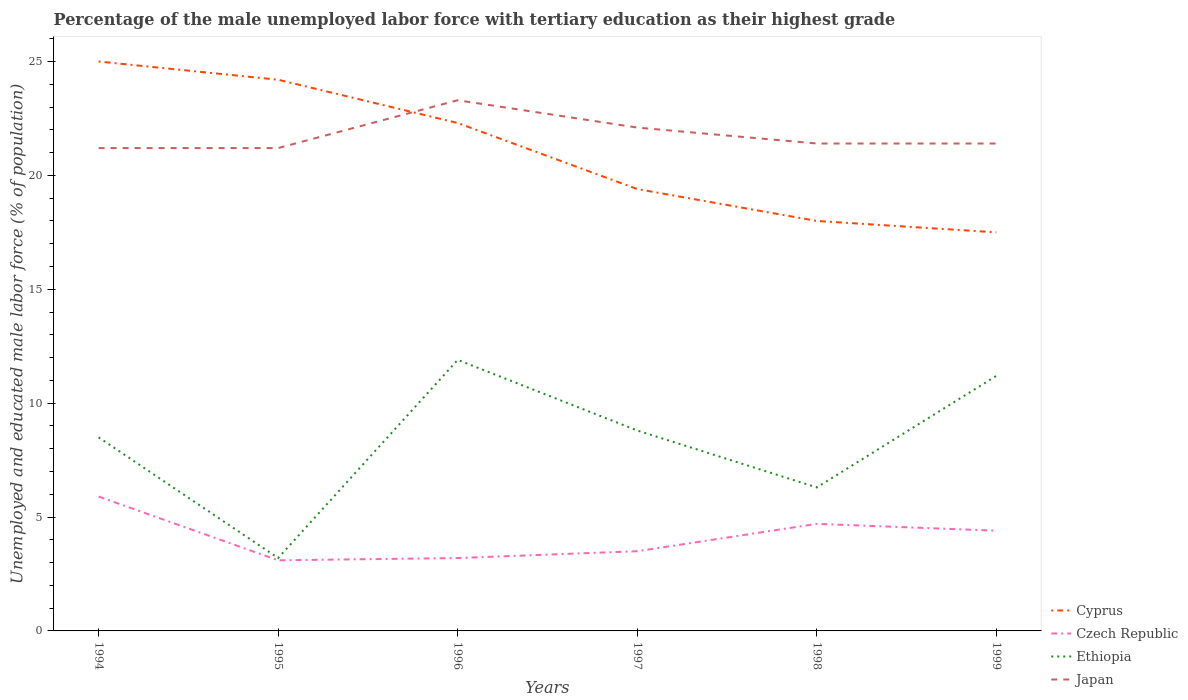How many different coloured lines are there?
Offer a very short reply. 4. Does the line corresponding to Cyprus intersect with the line corresponding to Ethiopia?
Offer a very short reply. No. Is the number of lines equal to the number of legend labels?
Provide a succinct answer. Yes. In which year was the percentage of the unemployed male labor force with tertiary education in Japan maximum?
Your answer should be compact. 1994. What is the total percentage of the unemployed male labor force with tertiary education in Cyprus in the graph?
Your answer should be compact. 4.8. What is the difference between the highest and the second highest percentage of the unemployed male labor force with tertiary education in Czech Republic?
Offer a terse response. 2.8. Is the percentage of the unemployed male labor force with tertiary education in Czech Republic strictly greater than the percentage of the unemployed male labor force with tertiary education in Cyprus over the years?
Give a very brief answer. Yes. How many lines are there?
Your response must be concise. 4. How many years are there in the graph?
Provide a short and direct response. 6. Are the values on the major ticks of Y-axis written in scientific E-notation?
Your answer should be very brief. No. Does the graph contain any zero values?
Keep it short and to the point. No. Does the graph contain grids?
Provide a short and direct response. No. How many legend labels are there?
Offer a very short reply. 4. How are the legend labels stacked?
Offer a very short reply. Vertical. What is the title of the graph?
Ensure brevity in your answer.  Percentage of the male unemployed labor force with tertiary education as their highest grade. Does "Nepal" appear as one of the legend labels in the graph?
Ensure brevity in your answer.  No. What is the label or title of the X-axis?
Keep it short and to the point. Years. What is the label or title of the Y-axis?
Give a very brief answer. Unemployed and educated male labor force (% of population). What is the Unemployed and educated male labor force (% of population) in Czech Republic in 1994?
Make the answer very short. 5.9. What is the Unemployed and educated male labor force (% of population) in Japan in 1994?
Give a very brief answer. 21.2. What is the Unemployed and educated male labor force (% of population) of Cyprus in 1995?
Give a very brief answer. 24.2. What is the Unemployed and educated male labor force (% of population) of Czech Republic in 1995?
Ensure brevity in your answer.  3.1. What is the Unemployed and educated male labor force (% of population) of Ethiopia in 1995?
Offer a terse response. 3.2. What is the Unemployed and educated male labor force (% of population) of Japan in 1995?
Your answer should be compact. 21.2. What is the Unemployed and educated male labor force (% of population) of Cyprus in 1996?
Make the answer very short. 22.3. What is the Unemployed and educated male labor force (% of population) in Czech Republic in 1996?
Ensure brevity in your answer.  3.2. What is the Unemployed and educated male labor force (% of population) in Ethiopia in 1996?
Give a very brief answer. 11.9. What is the Unemployed and educated male labor force (% of population) in Japan in 1996?
Provide a short and direct response. 23.3. What is the Unemployed and educated male labor force (% of population) of Cyprus in 1997?
Keep it short and to the point. 19.4. What is the Unemployed and educated male labor force (% of population) of Ethiopia in 1997?
Your answer should be very brief. 8.8. What is the Unemployed and educated male labor force (% of population) in Japan in 1997?
Your answer should be very brief. 22.1. What is the Unemployed and educated male labor force (% of population) in Cyprus in 1998?
Offer a very short reply. 18. What is the Unemployed and educated male labor force (% of population) in Czech Republic in 1998?
Provide a succinct answer. 4.7. What is the Unemployed and educated male labor force (% of population) in Ethiopia in 1998?
Your answer should be very brief. 6.3. What is the Unemployed and educated male labor force (% of population) of Japan in 1998?
Provide a short and direct response. 21.4. What is the Unemployed and educated male labor force (% of population) in Cyprus in 1999?
Offer a very short reply. 17.5. What is the Unemployed and educated male labor force (% of population) in Czech Republic in 1999?
Ensure brevity in your answer.  4.4. What is the Unemployed and educated male labor force (% of population) of Ethiopia in 1999?
Provide a succinct answer. 11.2. What is the Unemployed and educated male labor force (% of population) in Japan in 1999?
Your answer should be compact. 21.4. Across all years, what is the maximum Unemployed and educated male labor force (% of population) of Czech Republic?
Keep it short and to the point. 5.9. Across all years, what is the maximum Unemployed and educated male labor force (% of population) in Ethiopia?
Provide a succinct answer. 11.9. Across all years, what is the maximum Unemployed and educated male labor force (% of population) in Japan?
Offer a very short reply. 23.3. Across all years, what is the minimum Unemployed and educated male labor force (% of population) in Czech Republic?
Ensure brevity in your answer.  3.1. Across all years, what is the minimum Unemployed and educated male labor force (% of population) in Ethiopia?
Provide a succinct answer. 3.2. Across all years, what is the minimum Unemployed and educated male labor force (% of population) of Japan?
Provide a succinct answer. 21.2. What is the total Unemployed and educated male labor force (% of population) in Cyprus in the graph?
Give a very brief answer. 126.4. What is the total Unemployed and educated male labor force (% of population) in Czech Republic in the graph?
Your answer should be compact. 24.8. What is the total Unemployed and educated male labor force (% of population) of Ethiopia in the graph?
Ensure brevity in your answer.  49.9. What is the total Unemployed and educated male labor force (% of population) in Japan in the graph?
Ensure brevity in your answer.  130.6. What is the difference between the Unemployed and educated male labor force (% of population) of Cyprus in 1994 and that in 1995?
Your response must be concise. 0.8. What is the difference between the Unemployed and educated male labor force (% of population) in Czech Republic in 1994 and that in 1995?
Ensure brevity in your answer.  2.8. What is the difference between the Unemployed and educated male labor force (% of population) in Cyprus in 1994 and that in 1996?
Provide a succinct answer. 2.7. What is the difference between the Unemployed and educated male labor force (% of population) of Czech Republic in 1994 and that in 1996?
Give a very brief answer. 2.7. What is the difference between the Unemployed and educated male labor force (% of population) in Ethiopia in 1994 and that in 1996?
Keep it short and to the point. -3.4. What is the difference between the Unemployed and educated male labor force (% of population) in Japan in 1994 and that in 1996?
Provide a succinct answer. -2.1. What is the difference between the Unemployed and educated male labor force (% of population) of Czech Republic in 1994 and that in 1997?
Offer a very short reply. 2.4. What is the difference between the Unemployed and educated male labor force (% of population) of Ethiopia in 1994 and that in 1997?
Your response must be concise. -0.3. What is the difference between the Unemployed and educated male labor force (% of population) of Cyprus in 1994 and that in 1998?
Your answer should be very brief. 7. What is the difference between the Unemployed and educated male labor force (% of population) of Japan in 1994 and that in 1998?
Your answer should be very brief. -0.2. What is the difference between the Unemployed and educated male labor force (% of population) in Czech Republic in 1994 and that in 1999?
Offer a terse response. 1.5. What is the difference between the Unemployed and educated male labor force (% of population) of Ethiopia in 1994 and that in 1999?
Ensure brevity in your answer.  -2.7. What is the difference between the Unemployed and educated male labor force (% of population) in Cyprus in 1995 and that in 1996?
Your answer should be compact. 1.9. What is the difference between the Unemployed and educated male labor force (% of population) of Czech Republic in 1995 and that in 1997?
Offer a terse response. -0.4. What is the difference between the Unemployed and educated male labor force (% of population) in Japan in 1995 and that in 1997?
Your answer should be very brief. -0.9. What is the difference between the Unemployed and educated male labor force (% of population) of Cyprus in 1995 and that in 1998?
Offer a terse response. 6.2. What is the difference between the Unemployed and educated male labor force (% of population) of Czech Republic in 1995 and that in 1998?
Provide a succinct answer. -1.6. What is the difference between the Unemployed and educated male labor force (% of population) of Japan in 1995 and that in 1998?
Your response must be concise. -0.2. What is the difference between the Unemployed and educated male labor force (% of population) of Ethiopia in 1995 and that in 1999?
Your answer should be very brief. -8. What is the difference between the Unemployed and educated male labor force (% of population) of Japan in 1995 and that in 1999?
Give a very brief answer. -0.2. What is the difference between the Unemployed and educated male labor force (% of population) of Ethiopia in 1996 and that in 1997?
Offer a very short reply. 3.1. What is the difference between the Unemployed and educated male labor force (% of population) in Japan in 1996 and that in 1997?
Offer a very short reply. 1.2. What is the difference between the Unemployed and educated male labor force (% of population) in Cyprus in 1996 and that in 1998?
Make the answer very short. 4.3. What is the difference between the Unemployed and educated male labor force (% of population) in Czech Republic in 1996 and that in 1998?
Provide a succinct answer. -1.5. What is the difference between the Unemployed and educated male labor force (% of population) of Japan in 1996 and that in 1998?
Your answer should be compact. 1.9. What is the difference between the Unemployed and educated male labor force (% of population) of Cyprus in 1996 and that in 1999?
Your answer should be very brief. 4.8. What is the difference between the Unemployed and educated male labor force (% of population) in Ethiopia in 1996 and that in 1999?
Your answer should be very brief. 0.7. What is the difference between the Unemployed and educated male labor force (% of population) of Japan in 1996 and that in 1999?
Offer a terse response. 1.9. What is the difference between the Unemployed and educated male labor force (% of population) of Cyprus in 1997 and that in 1998?
Offer a very short reply. 1.4. What is the difference between the Unemployed and educated male labor force (% of population) of Czech Republic in 1997 and that in 1998?
Provide a short and direct response. -1.2. What is the difference between the Unemployed and educated male labor force (% of population) in Czech Republic in 1997 and that in 1999?
Give a very brief answer. -0.9. What is the difference between the Unemployed and educated male labor force (% of population) in Japan in 1997 and that in 1999?
Provide a short and direct response. 0.7. What is the difference between the Unemployed and educated male labor force (% of population) of Ethiopia in 1998 and that in 1999?
Your answer should be very brief. -4.9. What is the difference between the Unemployed and educated male labor force (% of population) of Cyprus in 1994 and the Unemployed and educated male labor force (% of population) of Czech Republic in 1995?
Ensure brevity in your answer.  21.9. What is the difference between the Unemployed and educated male labor force (% of population) of Cyprus in 1994 and the Unemployed and educated male labor force (% of population) of Ethiopia in 1995?
Make the answer very short. 21.8. What is the difference between the Unemployed and educated male labor force (% of population) of Cyprus in 1994 and the Unemployed and educated male labor force (% of population) of Japan in 1995?
Your response must be concise. 3.8. What is the difference between the Unemployed and educated male labor force (% of population) of Czech Republic in 1994 and the Unemployed and educated male labor force (% of population) of Ethiopia in 1995?
Provide a short and direct response. 2.7. What is the difference between the Unemployed and educated male labor force (% of population) in Czech Republic in 1994 and the Unemployed and educated male labor force (% of population) in Japan in 1995?
Your answer should be compact. -15.3. What is the difference between the Unemployed and educated male labor force (% of population) in Ethiopia in 1994 and the Unemployed and educated male labor force (% of population) in Japan in 1995?
Your answer should be very brief. -12.7. What is the difference between the Unemployed and educated male labor force (% of population) in Cyprus in 1994 and the Unemployed and educated male labor force (% of population) in Czech Republic in 1996?
Provide a short and direct response. 21.8. What is the difference between the Unemployed and educated male labor force (% of population) in Cyprus in 1994 and the Unemployed and educated male labor force (% of population) in Ethiopia in 1996?
Provide a short and direct response. 13.1. What is the difference between the Unemployed and educated male labor force (% of population) of Czech Republic in 1994 and the Unemployed and educated male labor force (% of population) of Japan in 1996?
Your response must be concise. -17.4. What is the difference between the Unemployed and educated male labor force (% of population) of Ethiopia in 1994 and the Unemployed and educated male labor force (% of population) of Japan in 1996?
Provide a succinct answer. -14.8. What is the difference between the Unemployed and educated male labor force (% of population) of Cyprus in 1994 and the Unemployed and educated male labor force (% of population) of Czech Republic in 1997?
Offer a terse response. 21.5. What is the difference between the Unemployed and educated male labor force (% of population) in Cyprus in 1994 and the Unemployed and educated male labor force (% of population) in Ethiopia in 1997?
Offer a terse response. 16.2. What is the difference between the Unemployed and educated male labor force (% of population) of Cyprus in 1994 and the Unemployed and educated male labor force (% of population) of Japan in 1997?
Offer a very short reply. 2.9. What is the difference between the Unemployed and educated male labor force (% of population) in Czech Republic in 1994 and the Unemployed and educated male labor force (% of population) in Japan in 1997?
Provide a short and direct response. -16.2. What is the difference between the Unemployed and educated male labor force (% of population) of Ethiopia in 1994 and the Unemployed and educated male labor force (% of population) of Japan in 1997?
Your answer should be very brief. -13.6. What is the difference between the Unemployed and educated male labor force (% of population) of Cyprus in 1994 and the Unemployed and educated male labor force (% of population) of Czech Republic in 1998?
Your answer should be compact. 20.3. What is the difference between the Unemployed and educated male labor force (% of population) of Cyprus in 1994 and the Unemployed and educated male labor force (% of population) of Japan in 1998?
Offer a terse response. 3.6. What is the difference between the Unemployed and educated male labor force (% of population) in Czech Republic in 1994 and the Unemployed and educated male labor force (% of population) in Ethiopia in 1998?
Ensure brevity in your answer.  -0.4. What is the difference between the Unemployed and educated male labor force (% of population) of Czech Republic in 1994 and the Unemployed and educated male labor force (% of population) of Japan in 1998?
Your answer should be very brief. -15.5. What is the difference between the Unemployed and educated male labor force (% of population) of Ethiopia in 1994 and the Unemployed and educated male labor force (% of population) of Japan in 1998?
Provide a succinct answer. -12.9. What is the difference between the Unemployed and educated male labor force (% of population) in Cyprus in 1994 and the Unemployed and educated male labor force (% of population) in Czech Republic in 1999?
Provide a succinct answer. 20.6. What is the difference between the Unemployed and educated male labor force (% of population) of Cyprus in 1994 and the Unemployed and educated male labor force (% of population) of Ethiopia in 1999?
Give a very brief answer. 13.8. What is the difference between the Unemployed and educated male labor force (% of population) in Czech Republic in 1994 and the Unemployed and educated male labor force (% of population) in Japan in 1999?
Offer a very short reply. -15.5. What is the difference between the Unemployed and educated male labor force (% of population) of Cyprus in 1995 and the Unemployed and educated male labor force (% of population) of Japan in 1996?
Make the answer very short. 0.9. What is the difference between the Unemployed and educated male labor force (% of population) of Czech Republic in 1995 and the Unemployed and educated male labor force (% of population) of Ethiopia in 1996?
Your response must be concise. -8.8. What is the difference between the Unemployed and educated male labor force (% of population) of Czech Republic in 1995 and the Unemployed and educated male labor force (% of population) of Japan in 1996?
Offer a very short reply. -20.2. What is the difference between the Unemployed and educated male labor force (% of population) in Ethiopia in 1995 and the Unemployed and educated male labor force (% of population) in Japan in 1996?
Your response must be concise. -20.1. What is the difference between the Unemployed and educated male labor force (% of population) of Cyprus in 1995 and the Unemployed and educated male labor force (% of population) of Czech Republic in 1997?
Your response must be concise. 20.7. What is the difference between the Unemployed and educated male labor force (% of population) in Cyprus in 1995 and the Unemployed and educated male labor force (% of population) in Japan in 1997?
Offer a very short reply. 2.1. What is the difference between the Unemployed and educated male labor force (% of population) of Ethiopia in 1995 and the Unemployed and educated male labor force (% of population) of Japan in 1997?
Offer a very short reply. -18.9. What is the difference between the Unemployed and educated male labor force (% of population) of Cyprus in 1995 and the Unemployed and educated male labor force (% of population) of Czech Republic in 1998?
Make the answer very short. 19.5. What is the difference between the Unemployed and educated male labor force (% of population) in Czech Republic in 1995 and the Unemployed and educated male labor force (% of population) in Japan in 1998?
Provide a succinct answer. -18.3. What is the difference between the Unemployed and educated male labor force (% of population) of Ethiopia in 1995 and the Unemployed and educated male labor force (% of population) of Japan in 1998?
Offer a terse response. -18.2. What is the difference between the Unemployed and educated male labor force (% of population) of Cyprus in 1995 and the Unemployed and educated male labor force (% of population) of Czech Republic in 1999?
Your response must be concise. 19.8. What is the difference between the Unemployed and educated male labor force (% of population) in Cyprus in 1995 and the Unemployed and educated male labor force (% of population) in Japan in 1999?
Your answer should be very brief. 2.8. What is the difference between the Unemployed and educated male labor force (% of population) in Czech Republic in 1995 and the Unemployed and educated male labor force (% of population) in Japan in 1999?
Keep it short and to the point. -18.3. What is the difference between the Unemployed and educated male labor force (% of population) in Ethiopia in 1995 and the Unemployed and educated male labor force (% of population) in Japan in 1999?
Make the answer very short. -18.2. What is the difference between the Unemployed and educated male labor force (% of population) of Cyprus in 1996 and the Unemployed and educated male labor force (% of population) of Japan in 1997?
Give a very brief answer. 0.2. What is the difference between the Unemployed and educated male labor force (% of population) in Czech Republic in 1996 and the Unemployed and educated male labor force (% of population) in Japan in 1997?
Offer a terse response. -18.9. What is the difference between the Unemployed and educated male labor force (% of population) in Cyprus in 1996 and the Unemployed and educated male labor force (% of population) in Czech Republic in 1998?
Ensure brevity in your answer.  17.6. What is the difference between the Unemployed and educated male labor force (% of population) of Czech Republic in 1996 and the Unemployed and educated male labor force (% of population) of Japan in 1998?
Give a very brief answer. -18.2. What is the difference between the Unemployed and educated male labor force (% of population) of Ethiopia in 1996 and the Unemployed and educated male labor force (% of population) of Japan in 1998?
Offer a terse response. -9.5. What is the difference between the Unemployed and educated male labor force (% of population) in Cyprus in 1996 and the Unemployed and educated male labor force (% of population) in Japan in 1999?
Give a very brief answer. 0.9. What is the difference between the Unemployed and educated male labor force (% of population) in Czech Republic in 1996 and the Unemployed and educated male labor force (% of population) in Japan in 1999?
Your response must be concise. -18.2. What is the difference between the Unemployed and educated male labor force (% of population) of Ethiopia in 1996 and the Unemployed and educated male labor force (% of population) of Japan in 1999?
Make the answer very short. -9.5. What is the difference between the Unemployed and educated male labor force (% of population) in Cyprus in 1997 and the Unemployed and educated male labor force (% of population) in Czech Republic in 1998?
Keep it short and to the point. 14.7. What is the difference between the Unemployed and educated male labor force (% of population) in Cyprus in 1997 and the Unemployed and educated male labor force (% of population) in Ethiopia in 1998?
Your answer should be compact. 13.1. What is the difference between the Unemployed and educated male labor force (% of population) in Czech Republic in 1997 and the Unemployed and educated male labor force (% of population) in Japan in 1998?
Your answer should be very brief. -17.9. What is the difference between the Unemployed and educated male labor force (% of population) of Ethiopia in 1997 and the Unemployed and educated male labor force (% of population) of Japan in 1998?
Your answer should be compact. -12.6. What is the difference between the Unemployed and educated male labor force (% of population) of Cyprus in 1997 and the Unemployed and educated male labor force (% of population) of Ethiopia in 1999?
Your answer should be very brief. 8.2. What is the difference between the Unemployed and educated male labor force (% of population) in Cyprus in 1997 and the Unemployed and educated male labor force (% of population) in Japan in 1999?
Provide a succinct answer. -2. What is the difference between the Unemployed and educated male labor force (% of population) in Czech Republic in 1997 and the Unemployed and educated male labor force (% of population) in Japan in 1999?
Your response must be concise. -17.9. What is the difference between the Unemployed and educated male labor force (% of population) of Cyprus in 1998 and the Unemployed and educated male labor force (% of population) of Ethiopia in 1999?
Provide a short and direct response. 6.8. What is the difference between the Unemployed and educated male labor force (% of population) of Czech Republic in 1998 and the Unemployed and educated male labor force (% of population) of Japan in 1999?
Make the answer very short. -16.7. What is the difference between the Unemployed and educated male labor force (% of population) of Ethiopia in 1998 and the Unemployed and educated male labor force (% of population) of Japan in 1999?
Keep it short and to the point. -15.1. What is the average Unemployed and educated male labor force (% of population) of Cyprus per year?
Your answer should be very brief. 21.07. What is the average Unemployed and educated male labor force (% of population) of Czech Republic per year?
Provide a succinct answer. 4.13. What is the average Unemployed and educated male labor force (% of population) of Ethiopia per year?
Your answer should be very brief. 8.32. What is the average Unemployed and educated male labor force (% of population) in Japan per year?
Your answer should be very brief. 21.77. In the year 1994, what is the difference between the Unemployed and educated male labor force (% of population) in Cyprus and Unemployed and educated male labor force (% of population) in Czech Republic?
Your response must be concise. 19.1. In the year 1994, what is the difference between the Unemployed and educated male labor force (% of population) of Czech Republic and Unemployed and educated male labor force (% of population) of Japan?
Ensure brevity in your answer.  -15.3. In the year 1995, what is the difference between the Unemployed and educated male labor force (% of population) in Cyprus and Unemployed and educated male labor force (% of population) in Czech Republic?
Ensure brevity in your answer.  21.1. In the year 1995, what is the difference between the Unemployed and educated male labor force (% of population) of Cyprus and Unemployed and educated male labor force (% of population) of Japan?
Your response must be concise. 3. In the year 1995, what is the difference between the Unemployed and educated male labor force (% of population) of Czech Republic and Unemployed and educated male labor force (% of population) of Japan?
Provide a short and direct response. -18.1. In the year 1995, what is the difference between the Unemployed and educated male labor force (% of population) in Ethiopia and Unemployed and educated male labor force (% of population) in Japan?
Ensure brevity in your answer.  -18. In the year 1996, what is the difference between the Unemployed and educated male labor force (% of population) of Cyprus and Unemployed and educated male labor force (% of population) of Ethiopia?
Offer a terse response. 10.4. In the year 1996, what is the difference between the Unemployed and educated male labor force (% of population) in Czech Republic and Unemployed and educated male labor force (% of population) in Japan?
Your answer should be very brief. -20.1. In the year 1996, what is the difference between the Unemployed and educated male labor force (% of population) of Ethiopia and Unemployed and educated male labor force (% of population) of Japan?
Ensure brevity in your answer.  -11.4. In the year 1997, what is the difference between the Unemployed and educated male labor force (% of population) of Cyprus and Unemployed and educated male labor force (% of population) of Czech Republic?
Provide a succinct answer. 15.9. In the year 1997, what is the difference between the Unemployed and educated male labor force (% of population) of Czech Republic and Unemployed and educated male labor force (% of population) of Japan?
Your answer should be compact. -18.6. In the year 1998, what is the difference between the Unemployed and educated male labor force (% of population) in Cyprus and Unemployed and educated male labor force (% of population) in Japan?
Offer a terse response. -3.4. In the year 1998, what is the difference between the Unemployed and educated male labor force (% of population) in Czech Republic and Unemployed and educated male labor force (% of population) in Ethiopia?
Ensure brevity in your answer.  -1.6. In the year 1998, what is the difference between the Unemployed and educated male labor force (% of population) of Czech Republic and Unemployed and educated male labor force (% of population) of Japan?
Your answer should be very brief. -16.7. In the year 1998, what is the difference between the Unemployed and educated male labor force (% of population) of Ethiopia and Unemployed and educated male labor force (% of population) of Japan?
Make the answer very short. -15.1. In the year 1999, what is the difference between the Unemployed and educated male labor force (% of population) of Czech Republic and Unemployed and educated male labor force (% of population) of Japan?
Provide a short and direct response. -17. In the year 1999, what is the difference between the Unemployed and educated male labor force (% of population) of Ethiopia and Unemployed and educated male labor force (% of population) of Japan?
Your response must be concise. -10.2. What is the ratio of the Unemployed and educated male labor force (% of population) in Cyprus in 1994 to that in 1995?
Give a very brief answer. 1.03. What is the ratio of the Unemployed and educated male labor force (% of population) in Czech Republic in 1994 to that in 1995?
Ensure brevity in your answer.  1.9. What is the ratio of the Unemployed and educated male labor force (% of population) of Ethiopia in 1994 to that in 1995?
Provide a succinct answer. 2.66. What is the ratio of the Unemployed and educated male labor force (% of population) in Cyprus in 1994 to that in 1996?
Provide a succinct answer. 1.12. What is the ratio of the Unemployed and educated male labor force (% of population) of Czech Republic in 1994 to that in 1996?
Make the answer very short. 1.84. What is the ratio of the Unemployed and educated male labor force (% of population) in Ethiopia in 1994 to that in 1996?
Your answer should be compact. 0.71. What is the ratio of the Unemployed and educated male labor force (% of population) of Japan in 1994 to that in 1996?
Keep it short and to the point. 0.91. What is the ratio of the Unemployed and educated male labor force (% of population) in Cyprus in 1994 to that in 1997?
Make the answer very short. 1.29. What is the ratio of the Unemployed and educated male labor force (% of population) of Czech Republic in 1994 to that in 1997?
Your answer should be very brief. 1.69. What is the ratio of the Unemployed and educated male labor force (% of population) in Ethiopia in 1994 to that in 1997?
Provide a short and direct response. 0.97. What is the ratio of the Unemployed and educated male labor force (% of population) of Japan in 1994 to that in 1997?
Your answer should be compact. 0.96. What is the ratio of the Unemployed and educated male labor force (% of population) of Cyprus in 1994 to that in 1998?
Keep it short and to the point. 1.39. What is the ratio of the Unemployed and educated male labor force (% of population) of Czech Republic in 1994 to that in 1998?
Your answer should be very brief. 1.26. What is the ratio of the Unemployed and educated male labor force (% of population) in Ethiopia in 1994 to that in 1998?
Provide a short and direct response. 1.35. What is the ratio of the Unemployed and educated male labor force (% of population) of Japan in 1994 to that in 1998?
Provide a succinct answer. 0.99. What is the ratio of the Unemployed and educated male labor force (% of population) in Cyprus in 1994 to that in 1999?
Provide a short and direct response. 1.43. What is the ratio of the Unemployed and educated male labor force (% of population) in Czech Republic in 1994 to that in 1999?
Provide a succinct answer. 1.34. What is the ratio of the Unemployed and educated male labor force (% of population) in Ethiopia in 1994 to that in 1999?
Your response must be concise. 0.76. What is the ratio of the Unemployed and educated male labor force (% of population) in Cyprus in 1995 to that in 1996?
Your response must be concise. 1.09. What is the ratio of the Unemployed and educated male labor force (% of population) in Czech Republic in 1995 to that in 1996?
Your answer should be compact. 0.97. What is the ratio of the Unemployed and educated male labor force (% of population) in Ethiopia in 1995 to that in 1996?
Offer a very short reply. 0.27. What is the ratio of the Unemployed and educated male labor force (% of population) in Japan in 1995 to that in 1996?
Your answer should be compact. 0.91. What is the ratio of the Unemployed and educated male labor force (% of population) in Cyprus in 1995 to that in 1997?
Ensure brevity in your answer.  1.25. What is the ratio of the Unemployed and educated male labor force (% of population) in Czech Republic in 1995 to that in 1997?
Your answer should be very brief. 0.89. What is the ratio of the Unemployed and educated male labor force (% of population) of Ethiopia in 1995 to that in 1997?
Provide a succinct answer. 0.36. What is the ratio of the Unemployed and educated male labor force (% of population) of Japan in 1995 to that in 1997?
Make the answer very short. 0.96. What is the ratio of the Unemployed and educated male labor force (% of population) of Cyprus in 1995 to that in 1998?
Your response must be concise. 1.34. What is the ratio of the Unemployed and educated male labor force (% of population) in Czech Republic in 1995 to that in 1998?
Provide a succinct answer. 0.66. What is the ratio of the Unemployed and educated male labor force (% of population) in Ethiopia in 1995 to that in 1998?
Ensure brevity in your answer.  0.51. What is the ratio of the Unemployed and educated male labor force (% of population) of Cyprus in 1995 to that in 1999?
Give a very brief answer. 1.38. What is the ratio of the Unemployed and educated male labor force (% of population) of Czech Republic in 1995 to that in 1999?
Provide a short and direct response. 0.7. What is the ratio of the Unemployed and educated male labor force (% of population) of Ethiopia in 1995 to that in 1999?
Your answer should be very brief. 0.29. What is the ratio of the Unemployed and educated male labor force (% of population) of Cyprus in 1996 to that in 1997?
Provide a succinct answer. 1.15. What is the ratio of the Unemployed and educated male labor force (% of population) of Czech Republic in 1996 to that in 1997?
Make the answer very short. 0.91. What is the ratio of the Unemployed and educated male labor force (% of population) in Ethiopia in 1996 to that in 1997?
Your response must be concise. 1.35. What is the ratio of the Unemployed and educated male labor force (% of population) of Japan in 1996 to that in 1997?
Offer a very short reply. 1.05. What is the ratio of the Unemployed and educated male labor force (% of population) of Cyprus in 1996 to that in 1998?
Your answer should be very brief. 1.24. What is the ratio of the Unemployed and educated male labor force (% of population) of Czech Republic in 1996 to that in 1998?
Offer a terse response. 0.68. What is the ratio of the Unemployed and educated male labor force (% of population) in Ethiopia in 1996 to that in 1998?
Provide a succinct answer. 1.89. What is the ratio of the Unemployed and educated male labor force (% of population) of Japan in 1996 to that in 1998?
Keep it short and to the point. 1.09. What is the ratio of the Unemployed and educated male labor force (% of population) of Cyprus in 1996 to that in 1999?
Provide a short and direct response. 1.27. What is the ratio of the Unemployed and educated male labor force (% of population) in Czech Republic in 1996 to that in 1999?
Keep it short and to the point. 0.73. What is the ratio of the Unemployed and educated male labor force (% of population) in Ethiopia in 1996 to that in 1999?
Your answer should be compact. 1.06. What is the ratio of the Unemployed and educated male labor force (% of population) in Japan in 1996 to that in 1999?
Ensure brevity in your answer.  1.09. What is the ratio of the Unemployed and educated male labor force (% of population) of Cyprus in 1997 to that in 1998?
Your answer should be very brief. 1.08. What is the ratio of the Unemployed and educated male labor force (% of population) in Czech Republic in 1997 to that in 1998?
Your response must be concise. 0.74. What is the ratio of the Unemployed and educated male labor force (% of population) in Ethiopia in 1997 to that in 1998?
Provide a succinct answer. 1.4. What is the ratio of the Unemployed and educated male labor force (% of population) of Japan in 1997 to that in 1998?
Give a very brief answer. 1.03. What is the ratio of the Unemployed and educated male labor force (% of population) in Cyprus in 1997 to that in 1999?
Provide a succinct answer. 1.11. What is the ratio of the Unemployed and educated male labor force (% of population) of Czech Republic in 1997 to that in 1999?
Offer a terse response. 0.8. What is the ratio of the Unemployed and educated male labor force (% of population) of Ethiopia in 1997 to that in 1999?
Your answer should be very brief. 0.79. What is the ratio of the Unemployed and educated male labor force (% of population) in Japan in 1997 to that in 1999?
Provide a succinct answer. 1.03. What is the ratio of the Unemployed and educated male labor force (% of population) of Cyprus in 1998 to that in 1999?
Provide a succinct answer. 1.03. What is the ratio of the Unemployed and educated male labor force (% of population) of Czech Republic in 1998 to that in 1999?
Your response must be concise. 1.07. What is the ratio of the Unemployed and educated male labor force (% of population) in Ethiopia in 1998 to that in 1999?
Offer a very short reply. 0.56. What is the ratio of the Unemployed and educated male labor force (% of population) in Japan in 1998 to that in 1999?
Provide a short and direct response. 1. What is the difference between the highest and the second highest Unemployed and educated male labor force (% of population) of Cyprus?
Offer a terse response. 0.8. What is the difference between the highest and the second highest Unemployed and educated male labor force (% of population) of Czech Republic?
Keep it short and to the point. 1.2. What is the difference between the highest and the second highest Unemployed and educated male labor force (% of population) of Japan?
Make the answer very short. 1.2. What is the difference between the highest and the lowest Unemployed and educated male labor force (% of population) in Czech Republic?
Your answer should be compact. 2.8. What is the difference between the highest and the lowest Unemployed and educated male labor force (% of population) in Ethiopia?
Your answer should be very brief. 8.7. What is the difference between the highest and the lowest Unemployed and educated male labor force (% of population) of Japan?
Your answer should be compact. 2.1. 